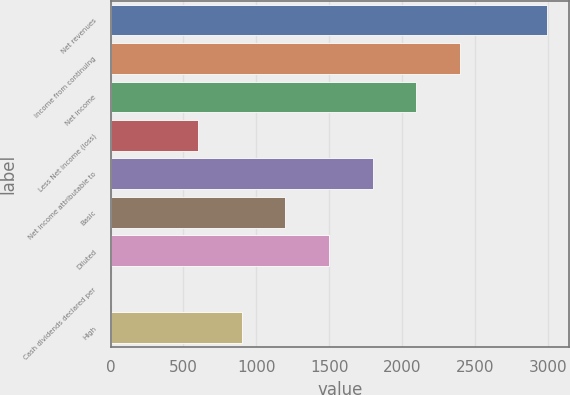Convert chart to OTSL. <chart><loc_0><loc_0><loc_500><loc_500><bar_chart><fcel>Net revenues<fcel>Income from continuing<fcel>Net income<fcel>Less Net income (loss)<fcel>Net income attributable to<fcel>Basic<fcel>Diluted<fcel>Cash dividends declared per<fcel>High<nl><fcel>2996.02<fcel>2396.92<fcel>2097.37<fcel>599.62<fcel>1797.82<fcel>1198.72<fcel>1498.27<fcel>0.52<fcel>899.17<nl></chart> 